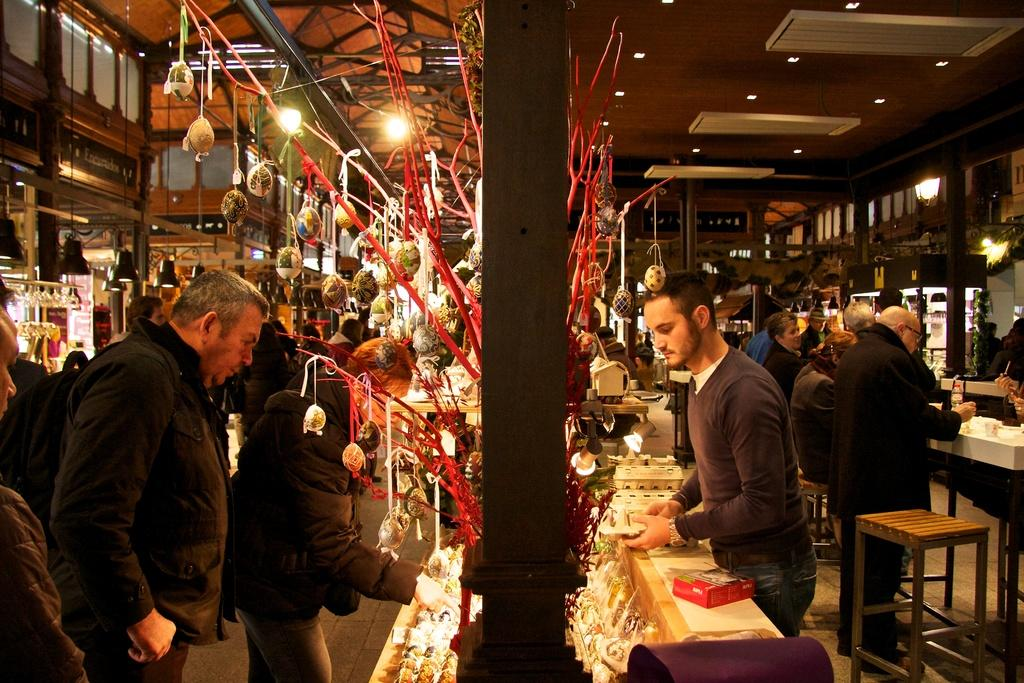What is the person in the image wearing? The person is wearing a black dress in the image. What is the person doing in the image? The person is looking at an object in a shop. Are there any other people around the person? Yes, there is a group of people in front of the person. What can be seen behind the person? There are stores visible behind the person. Is there a stream of water flowing through the shop where the person is looking at an object? No, there is no stream of water visible in the image. 